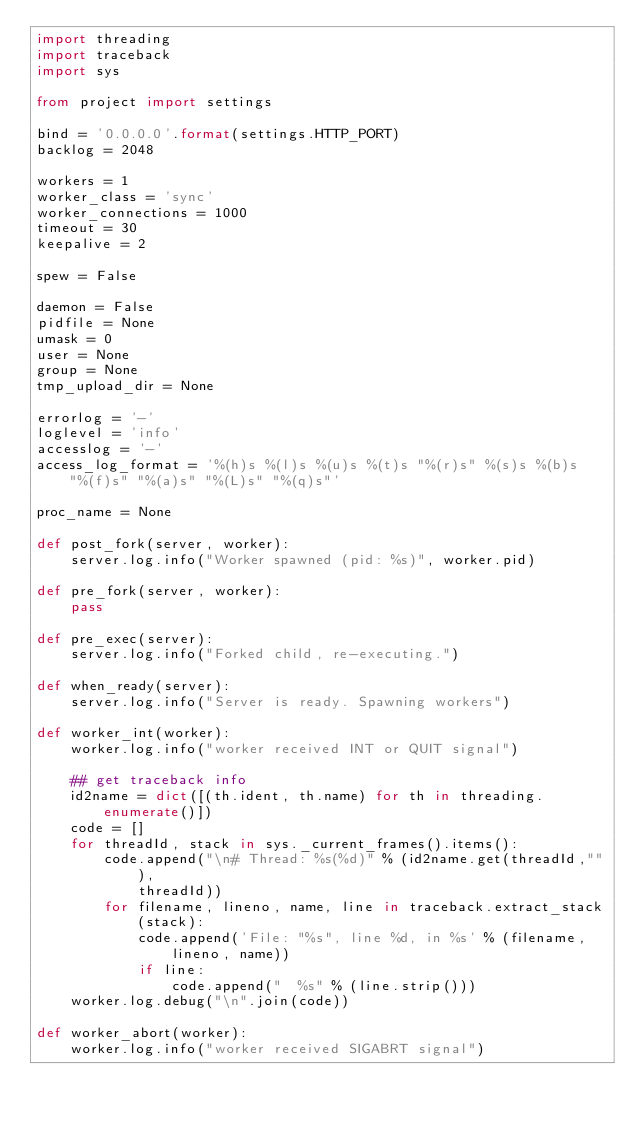Convert code to text. <code><loc_0><loc_0><loc_500><loc_500><_Python_>import threading
import traceback
import sys

from project import settings

bind = '0.0.0.0'.format(settings.HTTP_PORT)
backlog = 2048

workers = 1
worker_class = 'sync'
worker_connections = 1000
timeout = 30
keepalive = 2

spew = False

daemon = False
pidfile = None
umask = 0
user = None
group = None
tmp_upload_dir = None

errorlog = '-'
loglevel = 'info'
accesslog = '-'
access_log_format = '%(h)s %(l)s %(u)s %(t)s "%(r)s" %(s)s %(b)s "%(f)s" "%(a)s" "%(L)s" "%(q)s"'

proc_name = None

def post_fork(server, worker):
    server.log.info("Worker spawned (pid: %s)", worker.pid)

def pre_fork(server, worker):
    pass

def pre_exec(server):
    server.log.info("Forked child, re-executing.")

def when_ready(server):
    server.log.info("Server is ready. Spawning workers")

def worker_int(worker):
    worker.log.info("worker received INT or QUIT signal")

    ## get traceback info
    id2name = dict([(th.ident, th.name) for th in threading.enumerate()])
    code = []
    for threadId, stack in sys._current_frames().items():
        code.append("\n# Thread: %s(%d)" % (id2name.get(threadId,""),
            threadId))
        for filename, lineno, name, line in traceback.extract_stack(stack):
            code.append('File: "%s", line %d, in %s' % (filename,
                lineno, name))
            if line:
                code.append("  %s" % (line.strip()))
    worker.log.debug("\n".join(code))

def worker_abort(worker):
    worker.log.info("worker received SIGABRT signal")
</code> 